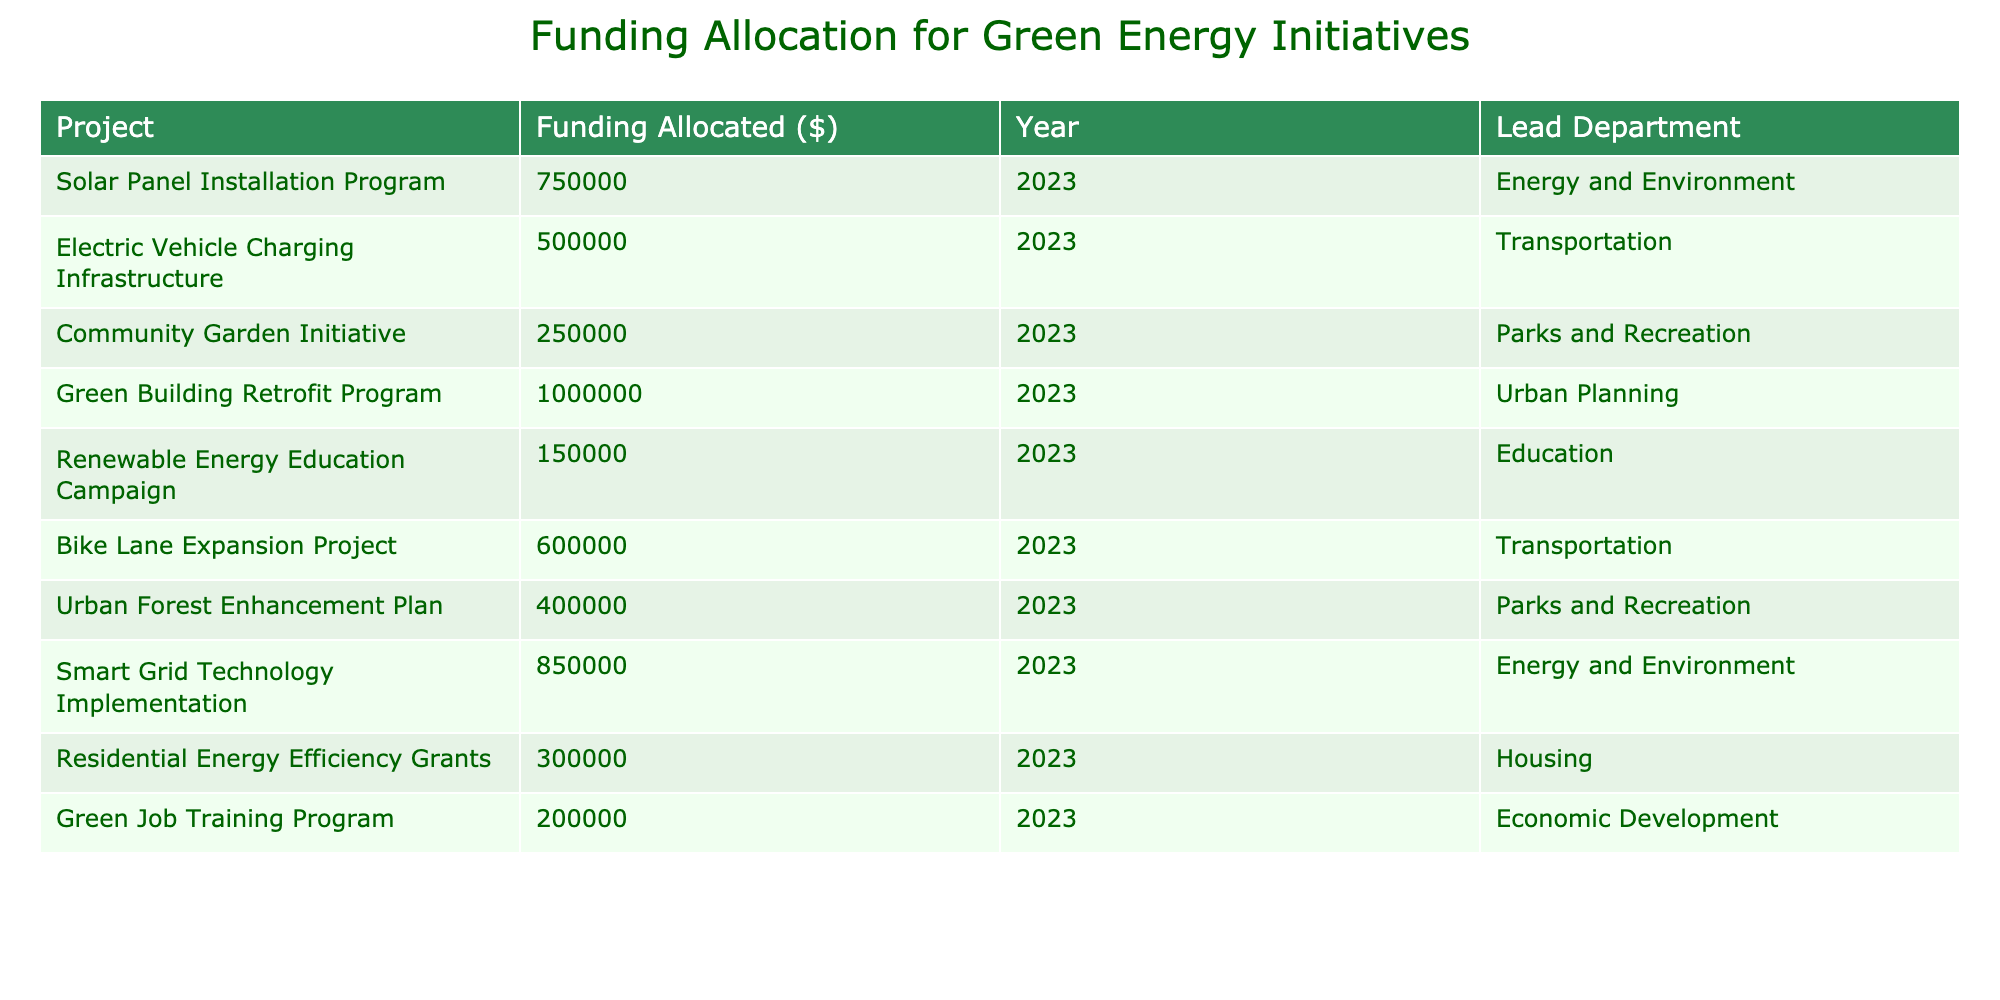What is the total funding allocated for green energy initiatives in 2023? To find the total funding, I will sum all the values in the "Funding Allocated ($)" column. The total is (750000 + 500000 + 250000 + 1000000 + 150000 + 600000 + 400000 + 850000 + 300000 + 200000) = 4550000.
Answer: 4550000 Which project received the highest funding? By looking at the "Funding Allocated ($)" column, the highest value is associated with the "Green Building Retrofit Program," which received 1000000.
Answer: Green Building Retrofit Program How many projects are funded in the "Transportation" department? I will count the number of projects listed under the "Transportation" department. There are two projects: "Electric Vehicle Charging Infrastructure" and "Bike Lane Expansion Project."
Answer: 2 What is the average funding allocation for projects under the "Parks and Recreation" department? The two projects in "Parks and Recreation" are "Community Garden Initiative" (250000) and "Urban Forest Enhancement Plan" (400000). I will calculate the sum (250000 + 400000 = 650000) and divide by the number of projects (2) to find the average, which is 650000 / 2 = 325000.
Answer: 325000 Did any project receive less than 300000 in funding? I will check the "Funding Allocated ($)" column for any values below 300000. The "Green Job Training Program" (200000) is less than 300000.
Answer: Yes What is the total funding allocated to projects led by the "Energy and Environment" department? There are two projects in "Energy and Environment": "Solar Panel Installation Program" (750000) and "Smart Grid Technology Implementation" (850000). The total funding is 750000 + 850000 = 1600000.
Answer: 1600000 How much more funding is allocated to the "Urban Planning" department than the "Education" department? For "Urban Planning," the funding is 1000000 for the "Green Building Retrofit Program." For "Education," the funding is 150000 for the "Renewable Energy Education Campaign." The difference is 1000000 - 150000 = 850000.
Answer: 850000 Which department has the lowest total funding across its projects? I will list the total funding for each department: "Energy and Environment" (1600000), "Transportation" (1100000), "Parks and Recreation" (650000), "Urban Planning" (1000000), "Education" (150000), and "Economic Development" (200000). The lowest is for "Economic Development" with 200000.
Answer: Economic Development Which project received exactly 600000 in funding? I will look at the "Funding Allocated ($)" column to find a project that matches 600000. The "Bike Lane Expansion Project" has this funding amount.
Answer: Bike Lane Expansion Project How many projects have funding allocations over 500000? I will count the projects in the "Funding Allocated ($)" column that exceed 500000. The projects are "Solar Panel Installation Program," "Green Building Retrofit Program," "Smart Grid Technology Implementation," "Electric Vehicle Charging Infrastructure," and "Bike Lane Expansion Project," totaling five projects.
Answer: 5 